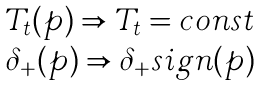Convert formula to latex. <formula><loc_0><loc_0><loc_500><loc_500>\begin{array} { l l } T _ { t } ( p ) \Rightarrow T _ { t } = c o n s t \\ \delta _ { + } ( p ) \Rightarrow \delta _ { + } s i g n ( p ) \end{array}</formula> 